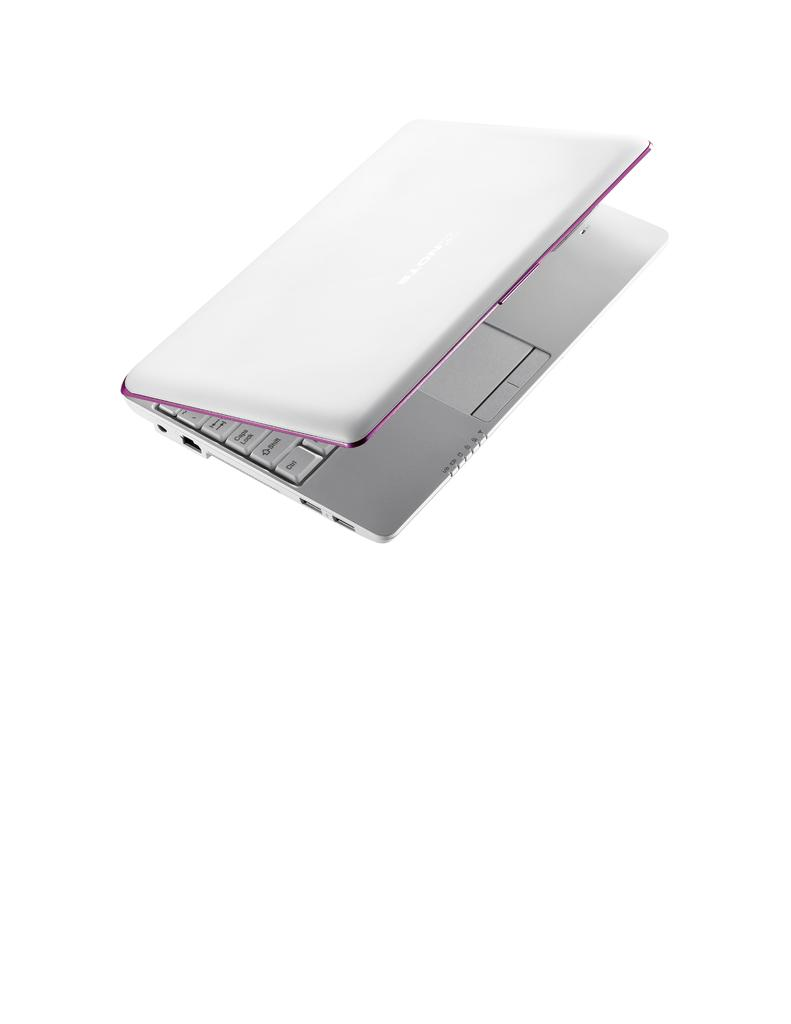What electronic device is visible in the image? There is a laptop in the image. What is the primary function of the device? The laptop is designed for computing and can be used for tasks such as browsing the internet, creating documents, and running software programs. Can you describe the appearance of the laptop? The laptop in the image appears to be a standard laptop with a screen, keyboard, and trackpad. How many babies are playing with the laptop in the image? There are no babies present in the image, and the laptop is not being used by anyone in the image. 